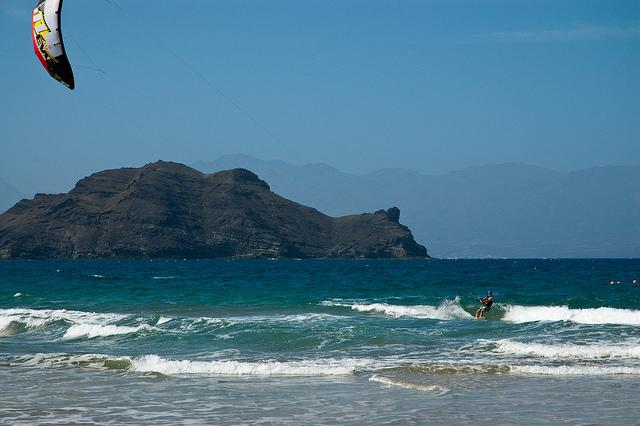What is he doing?

Choices:
A) swimming
B) resting
C) skiing
D) wind surfing wind surfing 